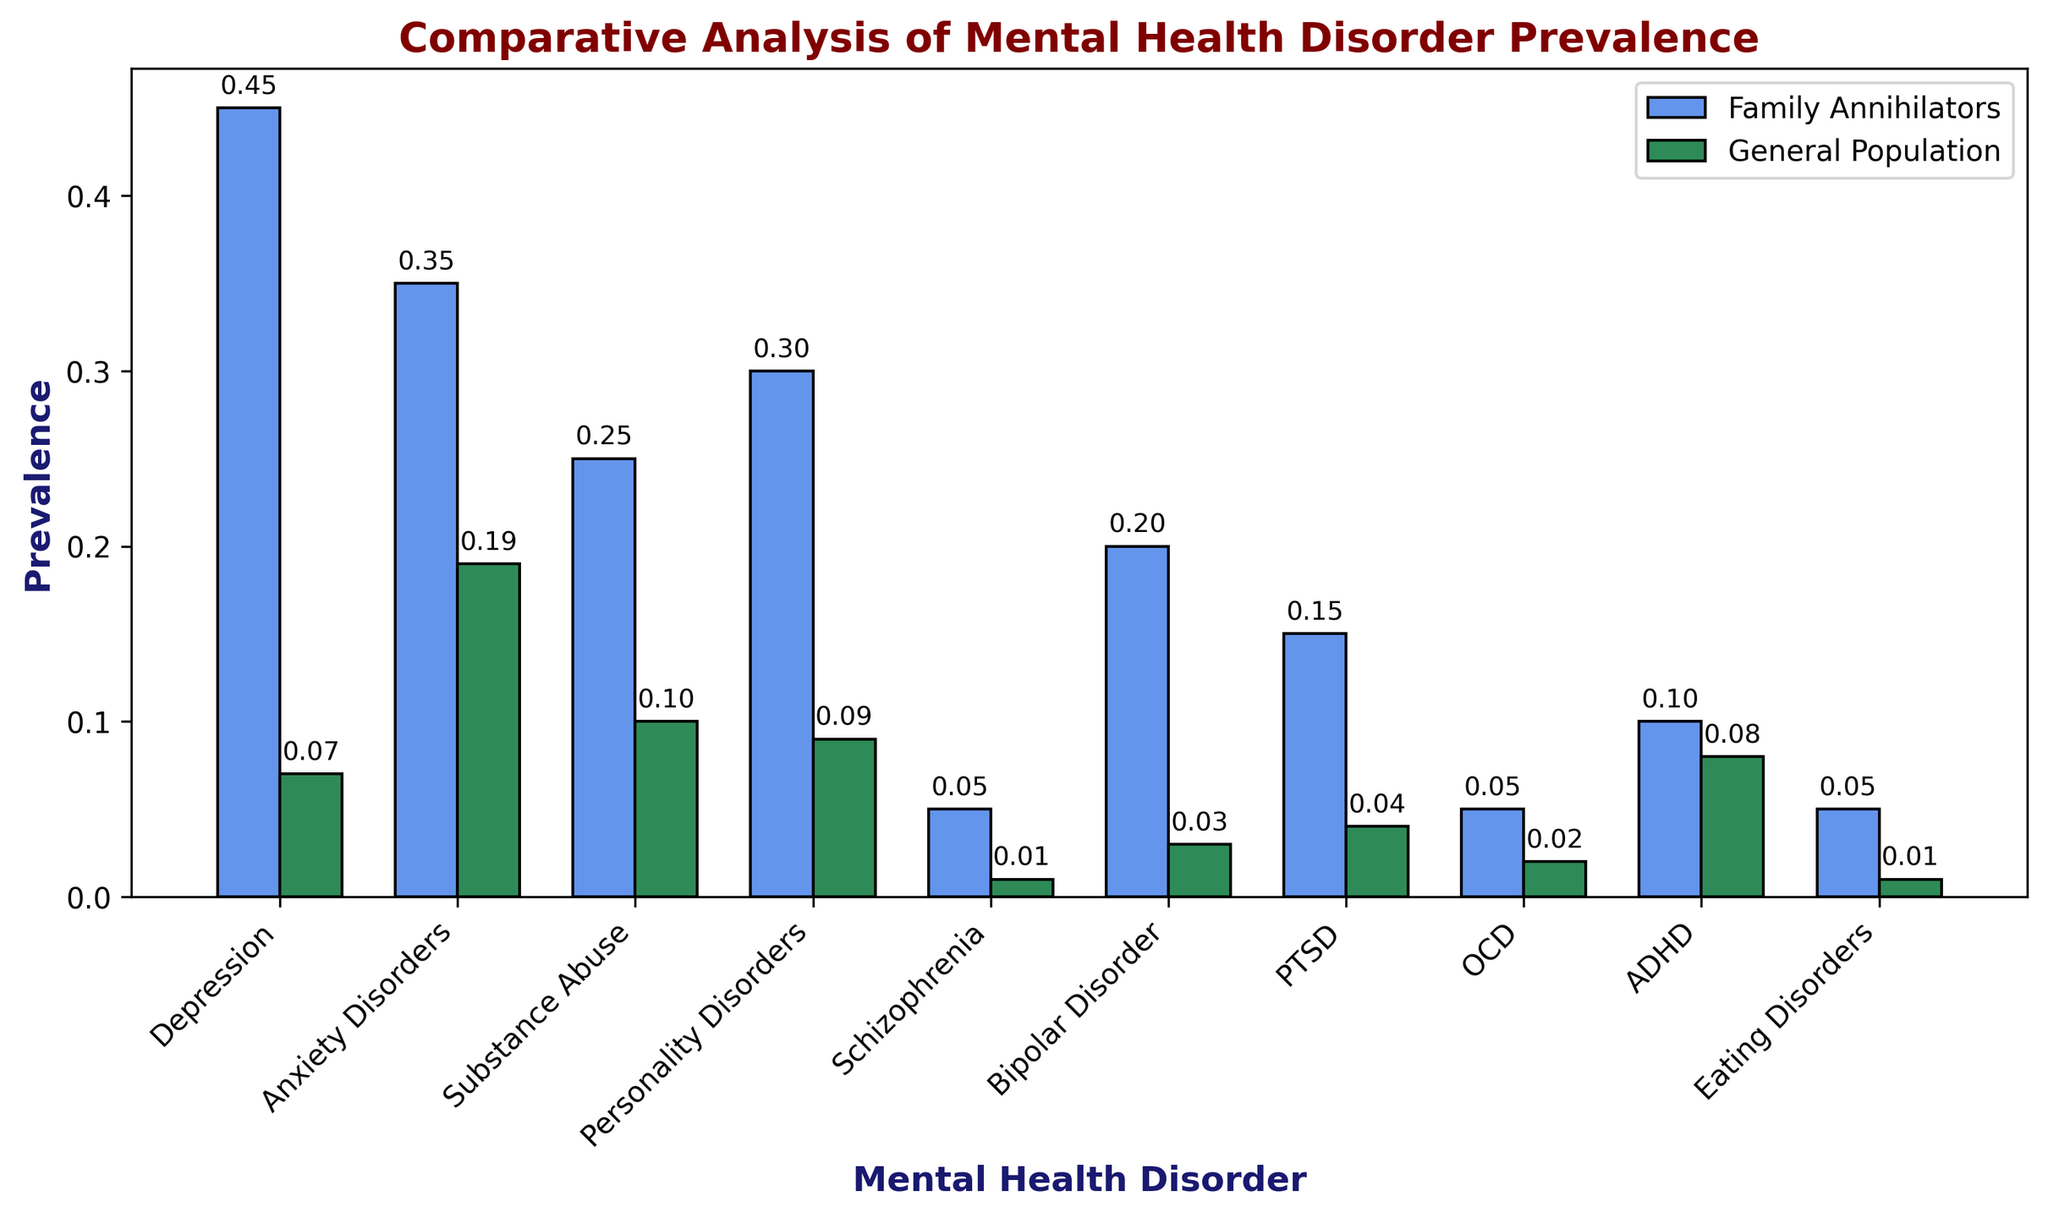What mental health disorder has the highest prevalence among family annihilators? By examining the height of the bars for the Family Annihilators group, we see that Depression has the highest bar with a value of 0.45.
Answer: Depression For which mental health disorder is the prevalence most similar between family annihilators and the general population? Comparing the heights of the bars, ADHD shows the smallest difference in height between the two groups, with values of 0.10 and 0.08 respectively.
Answer: ADHD What is the sum of the prevalence rates of anxiety disorders and PTSD in the general population? The prevalence rates are 0.19 for anxiety disorders and 0.04 for PTSD. Their sum is 0.19 + 0.04 = 0.23.
Answer: 0.23 Which mental health disorder has the largest difference in prevalence between family annihilators and the general population? By calculating the differences for each disorder, Depression shows the largest difference: 0.45 - 0.07 = 0.38.
Answer: Depression Is the prevalence of bipolar disorder higher in family annihilators or the general population? The height of the bar for Family Annihilators is 0.20, while for General Population it's 0.03. Thus, it's higher in Family Annihilators.
Answer: Family Annihilators Which mental health disorder is equally prevalent among both groups? Looking at the bars, no mental health disorder has exactly equal prevalence between the two groups.
Answer: None Among the listed mental health disorders, how many are more prevalent in the general population than in family annihilators? By comparing the heights of the bars, only ADHD has a higher prevalence in the general population than in family annihilators.
Answer: 1 disorder What is the average prevalence of eating disorders among both groups combined? The values are 0.05 for family annihilators and 0.01 for the general population. Their average is (0.05 + 0.01) / 2 = 0.03.
Answer: 0.03 Is the prevalence of schizophrenia in family annihilators significantly different from the general population? The bars show schizophrenia with 0.05 prevalence in family annihilators and 0.01 in the general population, indicating a notable difference.
Answer: Yes 